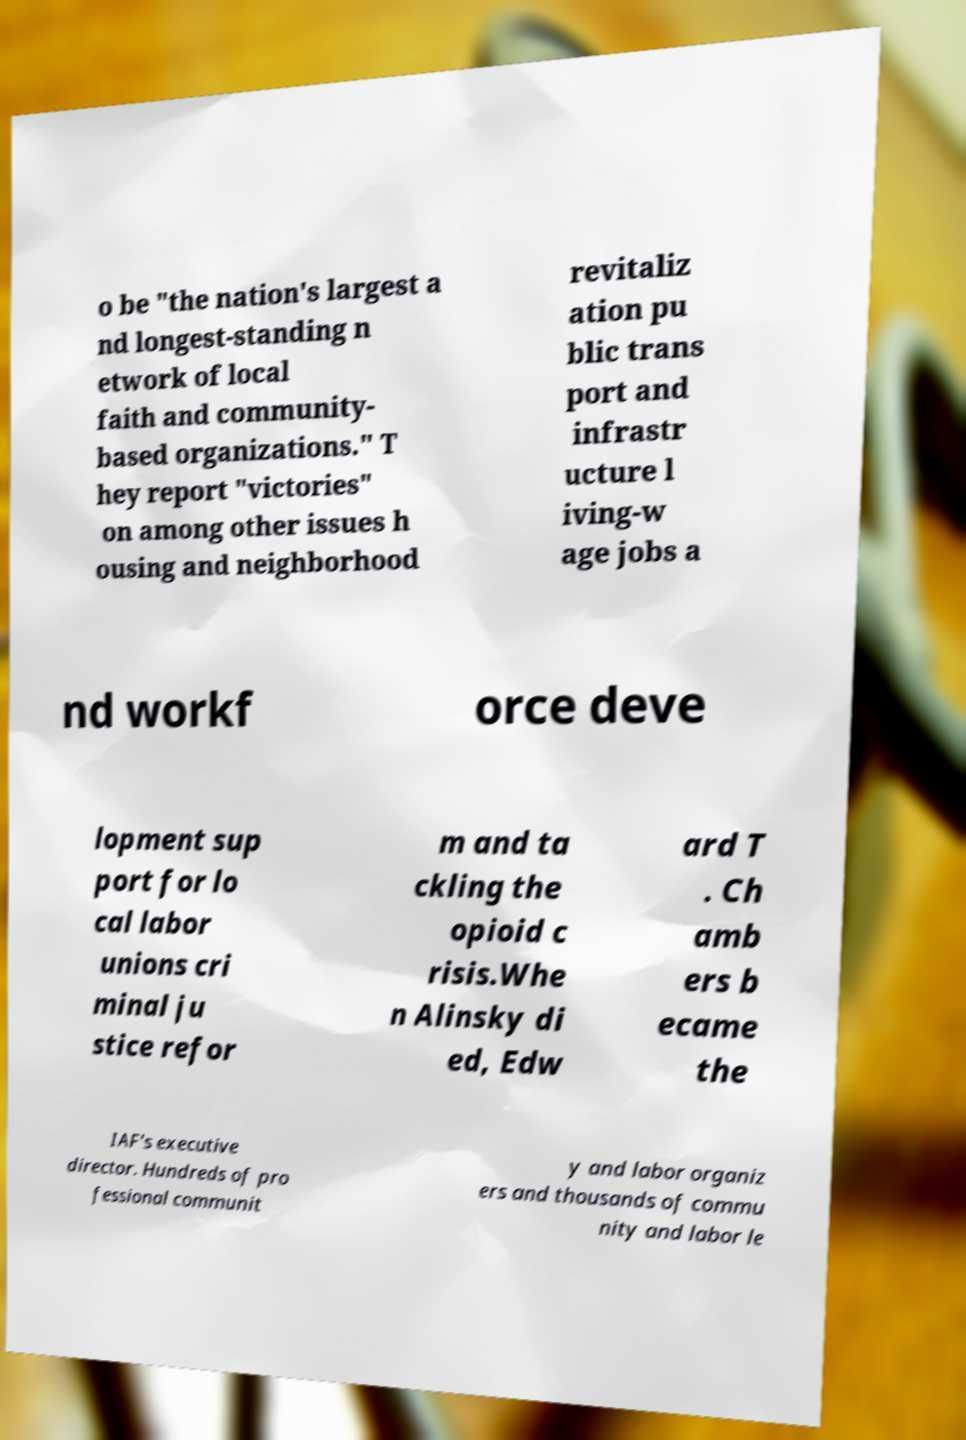Please read and relay the text visible in this image. What does it say? o be "the nation's largest a nd longest-standing n etwork of local faith and community- based organizations." T hey report "victories" on among other issues h ousing and neighborhood revitaliz ation pu blic trans port and infrastr ucture l iving-w age jobs a nd workf orce deve lopment sup port for lo cal labor unions cri minal ju stice refor m and ta ckling the opioid c risis.Whe n Alinsky di ed, Edw ard T . Ch amb ers b ecame the IAF's executive director. Hundreds of pro fessional communit y and labor organiz ers and thousands of commu nity and labor le 